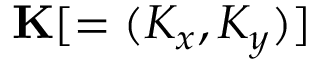Convert formula to latex. <formula><loc_0><loc_0><loc_500><loc_500>K [ = ( K _ { x } , K _ { y } ) ]</formula> 